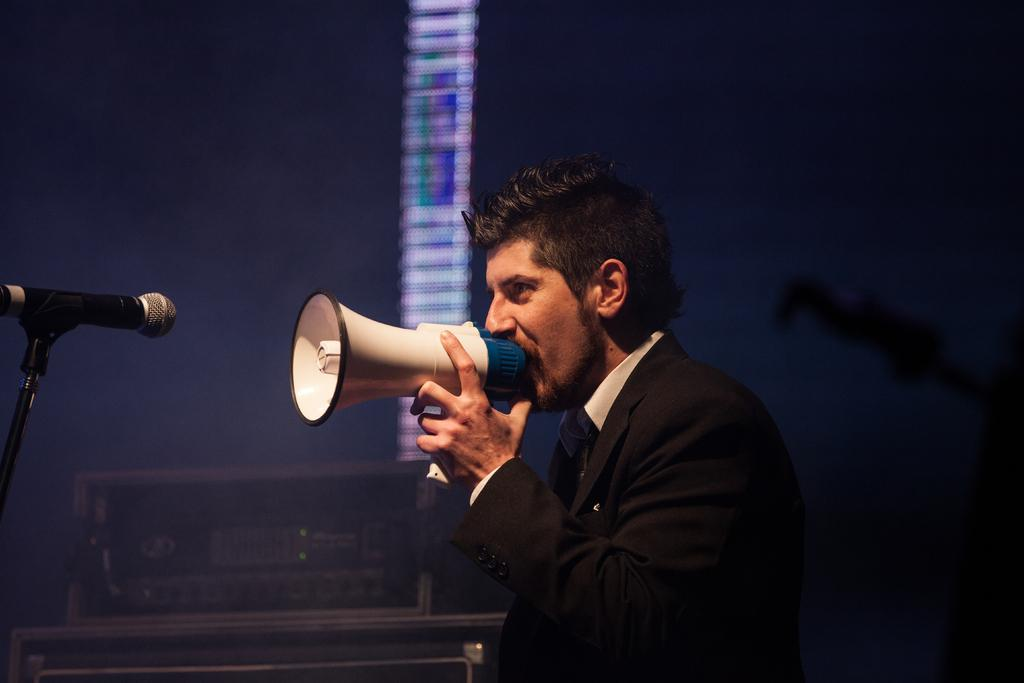Who is present in the image? There is a man in the image. What is the man wearing? The man is wearing a black blazer. What is the man doing in the image? The man is holding an item in front of a microphone. What color is the background of the man? The background of the man is blue. What other object related to music can be seen in the image? There is a music system in the image. What type of vase is placed on the music system in the image? There is no vase present in the image; the focus is on the man and the music system. 